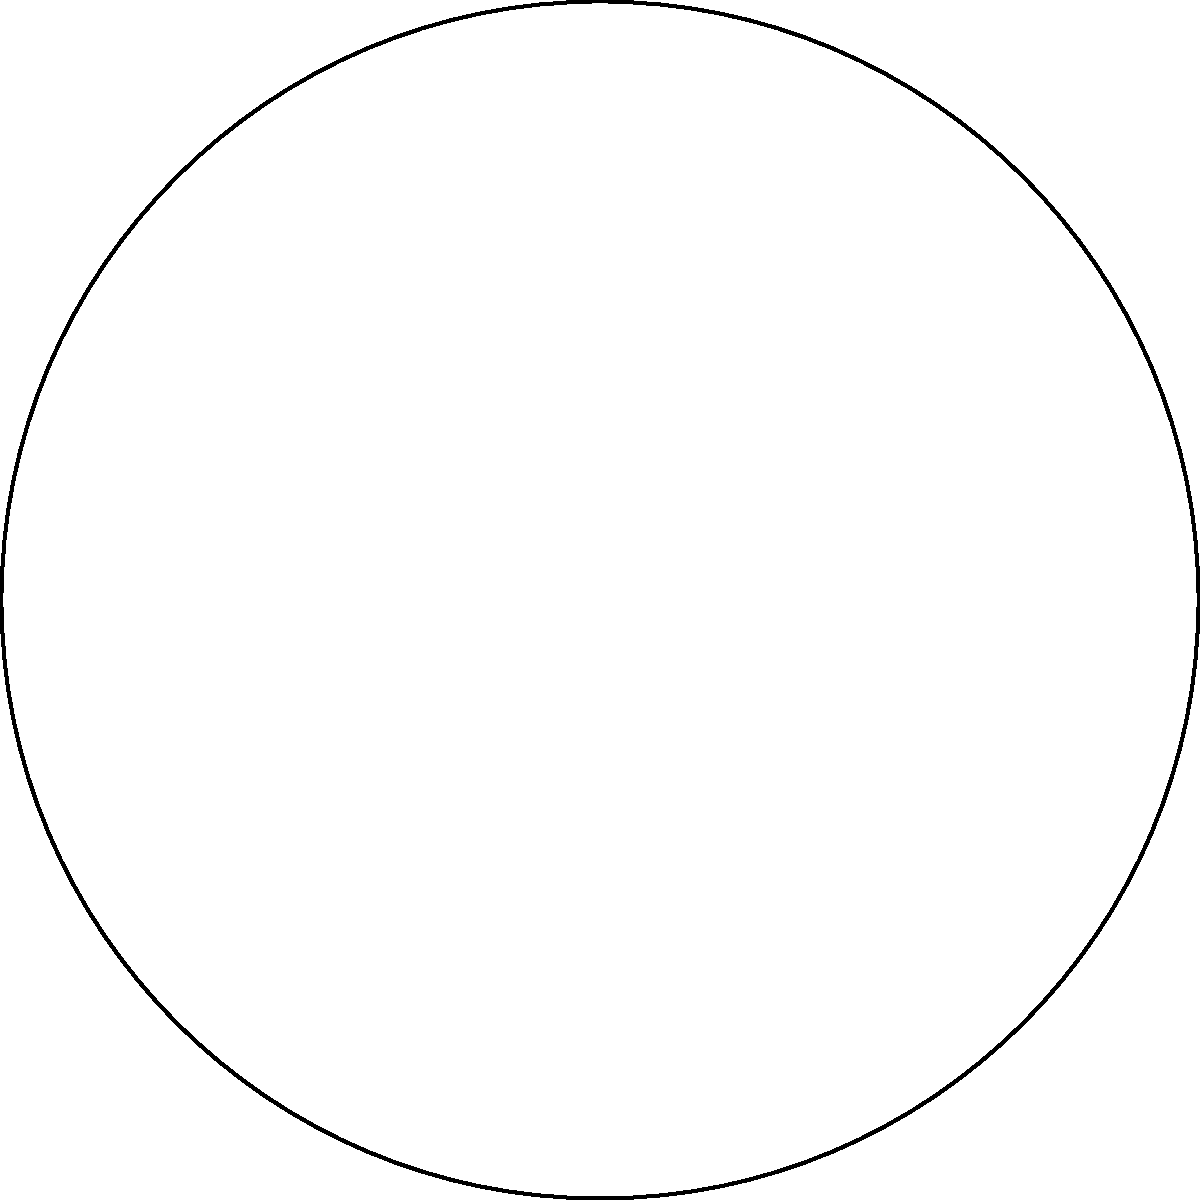In an open water swim race, a circular course is marked by buoys. The radius of the course is 300 meters, and the buoys are placed 260 meters from the center. If the angle between two consecutive buoys is 60°, what is the total distance swimmers must cover to complete one lap of the course? To solve this problem, we need to follow these steps:

1. Recognize that the swimmers will follow the circumference of the circle.

2. Recall the formula for the circumference of a circle:
   $$C = 2\pi r$$
   where $C$ is the circumference and $r$ is the radius.

3. Given information:
   - Radius $(r) = 300$ meters
   - Angle between buoys $= 60°$

4. Calculate the circumference:
   $$C = 2\pi r = 2\pi(300) = 600\pi \approx 1884.96$$ meters

5. The swimmers must cover this entire distance to complete one lap.

Note: The buoy placement at 260 meters from the center is not directly relevant to calculating the total swim distance, but it helps visualize the course layout and could be useful for other tactical considerations in the race.
Answer: $1884.96$ meters 